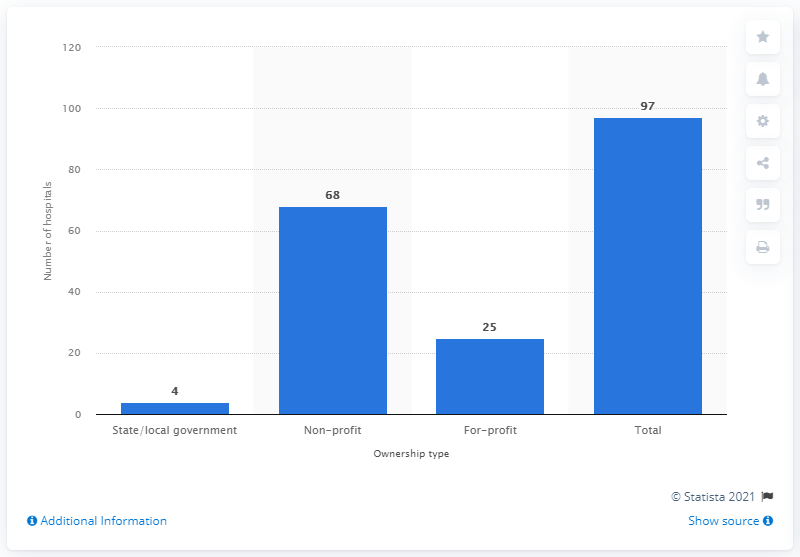Give some essential details in this illustration. There were 97 hospitals in the state of Virginia in 2019. 